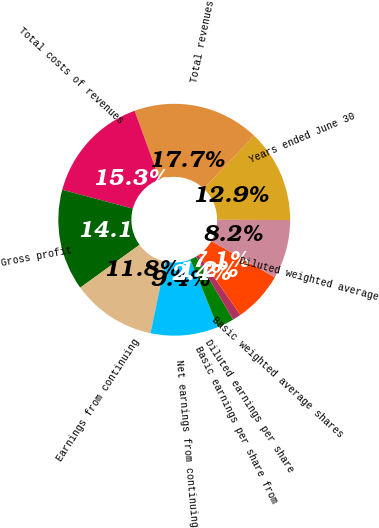Convert chart. <chart><loc_0><loc_0><loc_500><loc_500><pie_chart><fcel>Years ended June 30<fcel>Total revenues<fcel>Total costs of revenues<fcel>Gross profit<fcel>Earnings from continuing<fcel>Net earnings from continuing<fcel>Basic earnings per share from<fcel>Diluted earnings per share<fcel>Basic weighted average shares<fcel>Diluted weighted average<nl><fcel>12.94%<fcel>17.65%<fcel>15.29%<fcel>14.12%<fcel>11.76%<fcel>9.41%<fcel>2.35%<fcel>1.18%<fcel>7.06%<fcel>8.24%<nl></chart> 